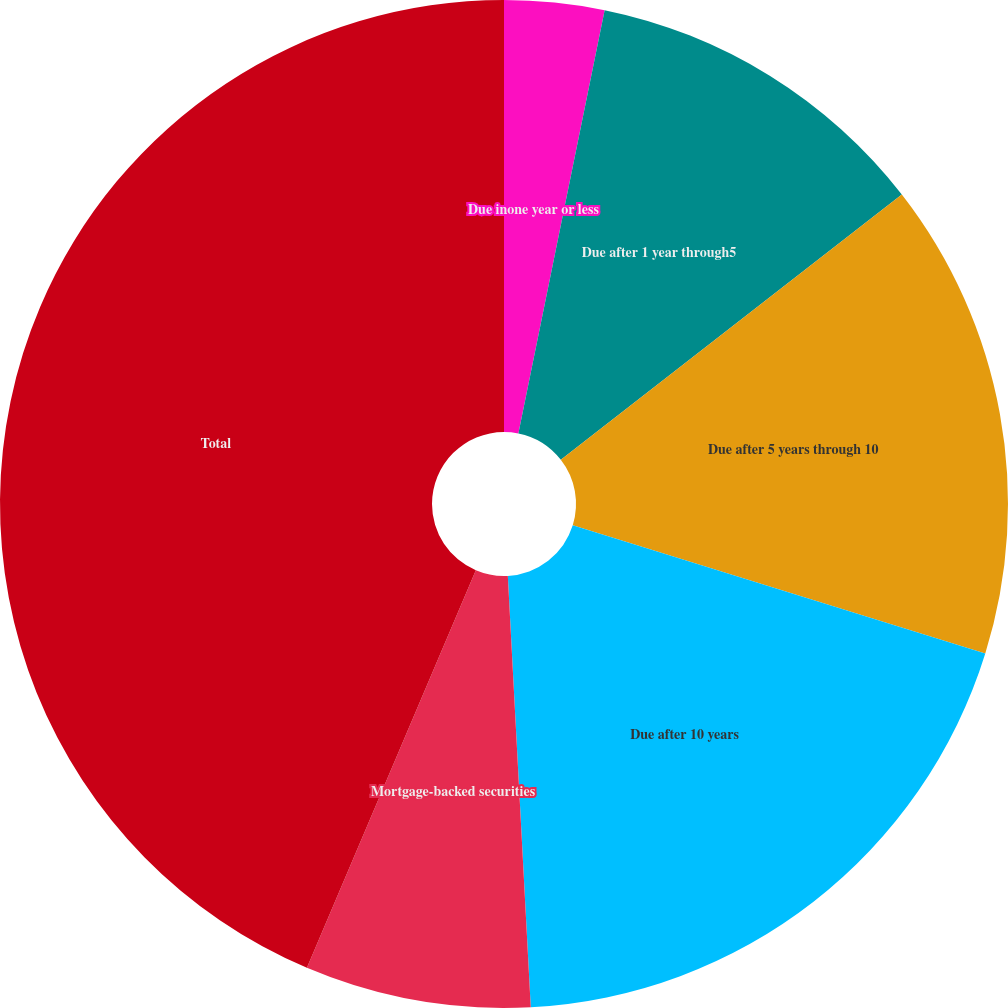Convert chart. <chart><loc_0><loc_0><loc_500><loc_500><pie_chart><fcel>Due inone year or less<fcel>Due after 1 year through5<fcel>Due after 5 years through 10<fcel>Due after 10 years<fcel>Mortgage-backed securities<fcel>Total<nl><fcel>3.2%<fcel>11.28%<fcel>15.32%<fcel>19.36%<fcel>7.24%<fcel>43.61%<nl></chart> 